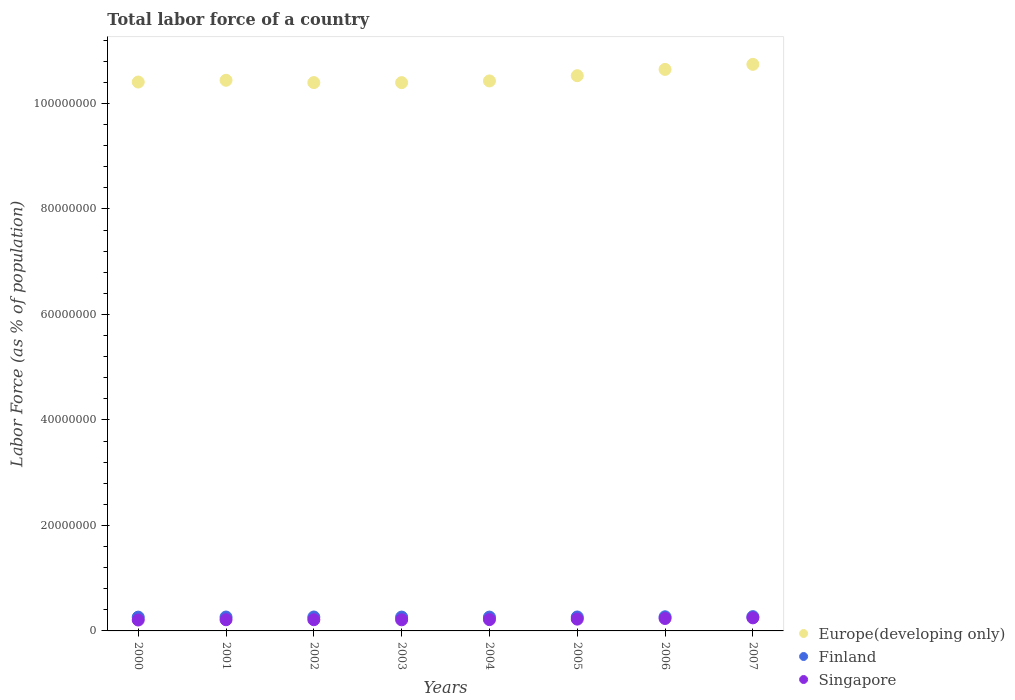How many different coloured dotlines are there?
Offer a terse response. 3. Is the number of dotlines equal to the number of legend labels?
Give a very brief answer. Yes. What is the percentage of labor force in Europe(developing only) in 2006?
Give a very brief answer. 1.06e+08. Across all years, what is the maximum percentage of labor force in Finland?
Give a very brief answer. 2.71e+06. Across all years, what is the minimum percentage of labor force in Singapore?
Your answer should be compact. 2.07e+06. In which year was the percentage of labor force in Europe(developing only) maximum?
Keep it short and to the point. 2007. In which year was the percentage of labor force in Finland minimum?
Keep it short and to the point. 2000. What is the total percentage of labor force in Finland in the graph?
Keep it short and to the point. 2.12e+07. What is the difference between the percentage of labor force in Finland in 2000 and that in 2003?
Your answer should be compact. -1.34e+04. What is the difference between the percentage of labor force in Finland in 2006 and the percentage of labor force in Europe(developing only) in 2002?
Offer a very short reply. -1.01e+08. What is the average percentage of labor force in Finland per year?
Provide a short and direct response. 2.65e+06. In the year 2002, what is the difference between the percentage of labor force in Finland and percentage of labor force in Singapore?
Your answer should be very brief. 5.14e+05. In how many years, is the percentage of labor force in Finland greater than 100000000 %?
Your answer should be compact. 0. What is the ratio of the percentage of labor force in Europe(developing only) in 2005 to that in 2007?
Make the answer very short. 0.98. Is the difference between the percentage of labor force in Finland in 2001 and 2006 greater than the difference between the percentage of labor force in Singapore in 2001 and 2006?
Provide a short and direct response. Yes. What is the difference between the highest and the second highest percentage of labor force in Singapore?
Your response must be concise. 1.21e+05. What is the difference between the highest and the lowest percentage of labor force in Finland?
Your answer should be very brief. 9.31e+04. Is the sum of the percentage of labor force in Finland in 2005 and 2007 greater than the maximum percentage of labor force in Singapore across all years?
Offer a very short reply. Yes. Does the percentage of labor force in Singapore monotonically increase over the years?
Ensure brevity in your answer.  No. How many dotlines are there?
Your answer should be compact. 3. What is the difference between two consecutive major ticks on the Y-axis?
Provide a short and direct response. 2.00e+07. Does the graph contain any zero values?
Make the answer very short. No. Where does the legend appear in the graph?
Make the answer very short. Bottom right. What is the title of the graph?
Your response must be concise. Total labor force of a country. Does "Central African Republic" appear as one of the legend labels in the graph?
Your answer should be very brief. No. What is the label or title of the Y-axis?
Provide a succinct answer. Labor Force (as % of population). What is the Labor Force (as % of population) in Europe(developing only) in 2000?
Offer a terse response. 1.04e+08. What is the Labor Force (as % of population) in Finland in 2000?
Ensure brevity in your answer.  2.61e+06. What is the Labor Force (as % of population) of Singapore in 2000?
Provide a succinct answer. 2.07e+06. What is the Labor Force (as % of population) in Europe(developing only) in 2001?
Provide a succinct answer. 1.04e+08. What is the Labor Force (as % of population) in Finland in 2001?
Ensure brevity in your answer.  2.63e+06. What is the Labor Force (as % of population) of Singapore in 2001?
Your answer should be very brief. 2.12e+06. What is the Labor Force (as % of population) of Europe(developing only) in 2002?
Keep it short and to the point. 1.04e+08. What is the Labor Force (as % of population) of Finland in 2002?
Offer a terse response. 2.64e+06. What is the Labor Force (as % of population) in Singapore in 2002?
Provide a short and direct response. 2.13e+06. What is the Labor Force (as % of population) of Europe(developing only) in 2003?
Keep it short and to the point. 1.04e+08. What is the Labor Force (as % of population) of Finland in 2003?
Offer a very short reply. 2.63e+06. What is the Labor Force (as % of population) in Singapore in 2003?
Offer a terse response. 2.11e+06. What is the Labor Force (as % of population) of Europe(developing only) in 2004?
Your response must be concise. 1.04e+08. What is the Labor Force (as % of population) in Finland in 2004?
Provide a succinct answer. 2.62e+06. What is the Labor Force (as % of population) of Singapore in 2004?
Provide a short and direct response. 2.14e+06. What is the Labor Force (as % of population) in Europe(developing only) in 2005?
Ensure brevity in your answer.  1.05e+08. What is the Labor Force (as % of population) in Finland in 2005?
Provide a short and direct response. 2.64e+06. What is the Labor Force (as % of population) in Singapore in 2005?
Offer a very short reply. 2.24e+06. What is the Labor Force (as % of population) of Europe(developing only) in 2006?
Provide a succinct answer. 1.06e+08. What is the Labor Force (as % of population) in Finland in 2006?
Your answer should be very brief. 2.68e+06. What is the Labor Force (as % of population) in Singapore in 2006?
Your response must be concise. 2.36e+06. What is the Labor Force (as % of population) of Europe(developing only) in 2007?
Offer a very short reply. 1.07e+08. What is the Labor Force (as % of population) of Finland in 2007?
Ensure brevity in your answer.  2.71e+06. What is the Labor Force (as % of population) in Singapore in 2007?
Provide a short and direct response. 2.48e+06. Across all years, what is the maximum Labor Force (as % of population) of Europe(developing only)?
Offer a terse response. 1.07e+08. Across all years, what is the maximum Labor Force (as % of population) in Finland?
Your answer should be compact. 2.71e+06. Across all years, what is the maximum Labor Force (as % of population) of Singapore?
Make the answer very short. 2.48e+06. Across all years, what is the minimum Labor Force (as % of population) of Europe(developing only)?
Provide a succinct answer. 1.04e+08. Across all years, what is the minimum Labor Force (as % of population) in Finland?
Ensure brevity in your answer.  2.61e+06. Across all years, what is the minimum Labor Force (as % of population) in Singapore?
Your answer should be compact. 2.07e+06. What is the total Labor Force (as % of population) in Europe(developing only) in the graph?
Provide a succinct answer. 8.40e+08. What is the total Labor Force (as % of population) of Finland in the graph?
Provide a short and direct response. 2.12e+07. What is the total Labor Force (as % of population) in Singapore in the graph?
Keep it short and to the point. 1.76e+07. What is the difference between the Labor Force (as % of population) in Europe(developing only) in 2000 and that in 2001?
Your answer should be compact. -3.35e+05. What is the difference between the Labor Force (as % of population) in Finland in 2000 and that in 2001?
Your answer should be very brief. -1.84e+04. What is the difference between the Labor Force (as % of population) of Singapore in 2000 and that in 2001?
Make the answer very short. -5.27e+04. What is the difference between the Labor Force (as % of population) of Europe(developing only) in 2000 and that in 2002?
Make the answer very short. 1.06e+05. What is the difference between the Labor Force (as % of population) in Finland in 2000 and that in 2002?
Make the answer very short. -2.54e+04. What is the difference between the Labor Force (as % of population) of Singapore in 2000 and that in 2002?
Give a very brief answer. -5.63e+04. What is the difference between the Labor Force (as % of population) of Europe(developing only) in 2000 and that in 2003?
Offer a terse response. 1.16e+05. What is the difference between the Labor Force (as % of population) in Finland in 2000 and that in 2003?
Provide a succinct answer. -1.34e+04. What is the difference between the Labor Force (as % of population) of Singapore in 2000 and that in 2003?
Keep it short and to the point. -3.64e+04. What is the difference between the Labor Force (as % of population) in Europe(developing only) in 2000 and that in 2004?
Your answer should be very brief. -2.07e+05. What is the difference between the Labor Force (as % of population) in Finland in 2000 and that in 2004?
Your response must be concise. -7622. What is the difference between the Labor Force (as % of population) of Singapore in 2000 and that in 2004?
Your answer should be very brief. -7.34e+04. What is the difference between the Labor Force (as % of population) in Europe(developing only) in 2000 and that in 2005?
Your response must be concise. -1.20e+06. What is the difference between the Labor Force (as % of population) of Finland in 2000 and that in 2005?
Ensure brevity in your answer.  -3.06e+04. What is the difference between the Labor Force (as % of population) of Singapore in 2000 and that in 2005?
Ensure brevity in your answer.  -1.69e+05. What is the difference between the Labor Force (as % of population) in Europe(developing only) in 2000 and that in 2006?
Your response must be concise. -2.40e+06. What is the difference between the Labor Force (as % of population) in Finland in 2000 and that in 2006?
Your answer should be compact. -6.70e+04. What is the difference between the Labor Force (as % of population) of Singapore in 2000 and that in 2006?
Give a very brief answer. -2.88e+05. What is the difference between the Labor Force (as % of population) of Europe(developing only) in 2000 and that in 2007?
Offer a very short reply. -3.35e+06. What is the difference between the Labor Force (as % of population) of Finland in 2000 and that in 2007?
Your response must be concise. -9.31e+04. What is the difference between the Labor Force (as % of population) in Singapore in 2000 and that in 2007?
Offer a terse response. -4.09e+05. What is the difference between the Labor Force (as % of population) in Europe(developing only) in 2001 and that in 2002?
Your response must be concise. 4.41e+05. What is the difference between the Labor Force (as % of population) of Finland in 2001 and that in 2002?
Provide a succinct answer. -7029. What is the difference between the Labor Force (as % of population) of Singapore in 2001 and that in 2002?
Your answer should be compact. -3507. What is the difference between the Labor Force (as % of population) in Europe(developing only) in 2001 and that in 2003?
Your answer should be compact. 4.51e+05. What is the difference between the Labor Force (as % of population) of Finland in 2001 and that in 2003?
Ensure brevity in your answer.  4950. What is the difference between the Labor Force (as % of population) of Singapore in 2001 and that in 2003?
Your response must be concise. 1.63e+04. What is the difference between the Labor Force (as % of population) of Europe(developing only) in 2001 and that in 2004?
Offer a terse response. 1.28e+05. What is the difference between the Labor Force (as % of population) of Finland in 2001 and that in 2004?
Your response must be concise. 1.08e+04. What is the difference between the Labor Force (as % of population) in Singapore in 2001 and that in 2004?
Offer a very short reply. -2.07e+04. What is the difference between the Labor Force (as % of population) in Europe(developing only) in 2001 and that in 2005?
Your answer should be compact. -8.66e+05. What is the difference between the Labor Force (as % of population) of Finland in 2001 and that in 2005?
Offer a very short reply. -1.22e+04. What is the difference between the Labor Force (as % of population) in Singapore in 2001 and that in 2005?
Offer a terse response. -1.17e+05. What is the difference between the Labor Force (as % of population) in Europe(developing only) in 2001 and that in 2006?
Provide a short and direct response. -2.06e+06. What is the difference between the Labor Force (as % of population) of Finland in 2001 and that in 2006?
Give a very brief answer. -4.86e+04. What is the difference between the Labor Force (as % of population) of Singapore in 2001 and that in 2006?
Ensure brevity in your answer.  -2.36e+05. What is the difference between the Labor Force (as % of population) of Europe(developing only) in 2001 and that in 2007?
Offer a very short reply. -3.02e+06. What is the difference between the Labor Force (as % of population) in Finland in 2001 and that in 2007?
Provide a short and direct response. -7.47e+04. What is the difference between the Labor Force (as % of population) in Singapore in 2001 and that in 2007?
Give a very brief answer. -3.56e+05. What is the difference between the Labor Force (as % of population) of Europe(developing only) in 2002 and that in 2003?
Provide a succinct answer. 1.04e+04. What is the difference between the Labor Force (as % of population) in Finland in 2002 and that in 2003?
Your response must be concise. 1.20e+04. What is the difference between the Labor Force (as % of population) of Singapore in 2002 and that in 2003?
Offer a very short reply. 1.98e+04. What is the difference between the Labor Force (as % of population) in Europe(developing only) in 2002 and that in 2004?
Your answer should be very brief. -3.12e+05. What is the difference between the Labor Force (as % of population) of Finland in 2002 and that in 2004?
Provide a succinct answer. 1.78e+04. What is the difference between the Labor Force (as % of population) in Singapore in 2002 and that in 2004?
Offer a terse response. -1.71e+04. What is the difference between the Labor Force (as % of population) in Europe(developing only) in 2002 and that in 2005?
Ensure brevity in your answer.  -1.31e+06. What is the difference between the Labor Force (as % of population) of Finland in 2002 and that in 2005?
Offer a very short reply. -5212. What is the difference between the Labor Force (as % of population) of Singapore in 2002 and that in 2005?
Provide a succinct answer. -1.13e+05. What is the difference between the Labor Force (as % of population) of Europe(developing only) in 2002 and that in 2006?
Offer a terse response. -2.50e+06. What is the difference between the Labor Force (as % of population) of Finland in 2002 and that in 2006?
Ensure brevity in your answer.  -4.16e+04. What is the difference between the Labor Force (as % of population) in Singapore in 2002 and that in 2006?
Your answer should be very brief. -2.32e+05. What is the difference between the Labor Force (as % of population) of Europe(developing only) in 2002 and that in 2007?
Your answer should be compact. -3.46e+06. What is the difference between the Labor Force (as % of population) in Finland in 2002 and that in 2007?
Your response must be concise. -6.77e+04. What is the difference between the Labor Force (as % of population) in Singapore in 2002 and that in 2007?
Your answer should be compact. -3.53e+05. What is the difference between the Labor Force (as % of population) in Europe(developing only) in 2003 and that in 2004?
Your answer should be very brief. -3.23e+05. What is the difference between the Labor Force (as % of population) in Finland in 2003 and that in 2004?
Offer a very short reply. 5801. What is the difference between the Labor Force (as % of population) of Singapore in 2003 and that in 2004?
Your response must be concise. -3.70e+04. What is the difference between the Labor Force (as % of population) in Europe(developing only) in 2003 and that in 2005?
Make the answer very short. -1.32e+06. What is the difference between the Labor Force (as % of population) of Finland in 2003 and that in 2005?
Ensure brevity in your answer.  -1.72e+04. What is the difference between the Labor Force (as % of population) of Singapore in 2003 and that in 2005?
Provide a succinct answer. -1.33e+05. What is the difference between the Labor Force (as % of population) in Europe(developing only) in 2003 and that in 2006?
Keep it short and to the point. -2.51e+06. What is the difference between the Labor Force (as % of population) in Finland in 2003 and that in 2006?
Offer a terse response. -5.36e+04. What is the difference between the Labor Force (as % of population) in Singapore in 2003 and that in 2006?
Make the answer very short. -2.52e+05. What is the difference between the Labor Force (as % of population) in Europe(developing only) in 2003 and that in 2007?
Keep it short and to the point. -3.47e+06. What is the difference between the Labor Force (as % of population) of Finland in 2003 and that in 2007?
Provide a short and direct response. -7.96e+04. What is the difference between the Labor Force (as % of population) in Singapore in 2003 and that in 2007?
Provide a succinct answer. -3.73e+05. What is the difference between the Labor Force (as % of population) of Europe(developing only) in 2004 and that in 2005?
Your answer should be very brief. -9.95e+05. What is the difference between the Labor Force (as % of population) in Finland in 2004 and that in 2005?
Your answer should be compact. -2.30e+04. What is the difference between the Labor Force (as % of population) of Singapore in 2004 and that in 2005?
Provide a short and direct response. -9.61e+04. What is the difference between the Labor Force (as % of population) in Europe(developing only) in 2004 and that in 2006?
Ensure brevity in your answer.  -2.19e+06. What is the difference between the Labor Force (as % of population) in Finland in 2004 and that in 2006?
Provide a short and direct response. -5.94e+04. What is the difference between the Labor Force (as % of population) in Singapore in 2004 and that in 2006?
Offer a very short reply. -2.15e+05. What is the difference between the Labor Force (as % of population) of Europe(developing only) in 2004 and that in 2007?
Keep it short and to the point. -3.14e+06. What is the difference between the Labor Force (as % of population) of Finland in 2004 and that in 2007?
Give a very brief answer. -8.54e+04. What is the difference between the Labor Force (as % of population) in Singapore in 2004 and that in 2007?
Keep it short and to the point. -3.36e+05. What is the difference between the Labor Force (as % of population) in Europe(developing only) in 2005 and that in 2006?
Provide a succinct answer. -1.19e+06. What is the difference between the Labor Force (as % of population) of Finland in 2005 and that in 2006?
Your answer should be compact. -3.64e+04. What is the difference between the Labor Force (as % of population) of Singapore in 2005 and that in 2006?
Provide a short and direct response. -1.19e+05. What is the difference between the Labor Force (as % of population) of Europe(developing only) in 2005 and that in 2007?
Provide a short and direct response. -2.15e+06. What is the difference between the Labor Force (as % of population) of Finland in 2005 and that in 2007?
Your answer should be compact. -6.25e+04. What is the difference between the Labor Force (as % of population) in Singapore in 2005 and that in 2007?
Give a very brief answer. -2.40e+05. What is the difference between the Labor Force (as % of population) of Europe(developing only) in 2006 and that in 2007?
Offer a very short reply. -9.56e+05. What is the difference between the Labor Force (as % of population) of Finland in 2006 and that in 2007?
Provide a succinct answer. -2.61e+04. What is the difference between the Labor Force (as % of population) in Singapore in 2006 and that in 2007?
Offer a terse response. -1.21e+05. What is the difference between the Labor Force (as % of population) in Europe(developing only) in 2000 and the Labor Force (as % of population) in Finland in 2001?
Make the answer very short. 1.01e+08. What is the difference between the Labor Force (as % of population) in Europe(developing only) in 2000 and the Labor Force (as % of population) in Singapore in 2001?
Provide a short and direct response. 1.02e+08. What is the difference between the Labor Force (as % of population) of Finland in 2000 and the Labor Force (as % of population) of Singapore in 2001?
Provide a short and direct response. 4.92e+05. What is the difference between the Labor Force (as % of population) in Europe(developing only) in 2000 and the Labor Force (as % of population) in Finland in 2002?
Make the answer very short. 1.01e+08. What is the difference between the Labor Force (as % of population) in Europe(developing only) in 2000 and the Labor Force (as % of population) in Singapore in 2002?
Your answer should be very brief. 1.02e+08. What is the difference between the Labor Force (as % of population) in Finland in 2000 and the Labor Force (as % of population) in Singapore in 2002?
Give a very brief answer. 4.89e+05. What is the difference between the Labor Force (as % of population) of Europe(developing only) in 2000 and the Labor Force (as % of population) of Finland in 2003?
Provide a succinct answer. 1.01e+08. What is the difference between the Labor Force (as % of population) in Europe(developing only) in 2000 and the Labor Force (as % of population) in Singapore in 2003?
Make the answer very short. 1.02e+08. What is the difference between the Labor Force (as % of population) in Finland in 2000 and the Labor Force (as % of population) in Singapore in 2003?
Offer a very short reply. 5.09e+05. What is the difference between the Labor Force (as % of population) of Europe(developing only) in 2000 and the Labor Force (as % of population) of Finland in 2004?
Make the answer very short. 1.01e+08. What is the difference between the Labor Force (as % of population) of Europe(developing only) in 2000 and the Labor Force (as % of population) of Singapore in 2004?
Your answer should be compact. 1.02e+08. What is the difference between the Labor Force (as % of population) in Finland in 2000 and the Labor Force (as % of population) in Singapore in 2004?
Offer a very short reply. 4.72e+05. What is the difference between the Labor Force (as % of population) in Europe(developing only) in 2000 and the Labor Force (as % of population) in Finland in 2005?
Make the answer very short. 1.01e+08. What is the difference between the Labor Force (as % of population) in Europe(developing only) in 2000 and the Labor Force (as % of population) in Singapore in 2005?
Provide a succinct answer. 1.02e+08. What is the difference between the Labor Force (as % of population) in Finland in 2000 and the Labor Force (as % of population) in Singapore in 2005?
Ensure brevity in your answer.  3.76e+05. What is the difference between the Labor Force (as % of population) of Europe(developing only) in 2000 and the Labor Force (as % of population) of Finland in 2006?
Give a very brief answer. 1.01e+08. What is the difference between the Labor Force (as % of population) in Europe(developing only) in 2000 and the Labor Force (as % of population) in Singapore in 2006?
Ensure brevity in your answer.  1.02e+08. What is the difference between the Labor Force (as % of population) of Finland in 2000 and the Labor Force (as % of population) of Singapore in 2006?
Provide a succinct answer. 2.57e+05. What is the difference between the Labor Force (as % of population) in Europe(developing only) in 2000 and the Labor Force (as % of population) in Finland in 2007?
Your answer should be compact. 1.01e+08. What is the difference between the Labor Force (as % of population) in Europe(developing only) in 2000 and the Labor Force (as % of population) in Singapore in 2007?
Your response must be concise. 1.02e+08. What is the difference between the Labor Force (as % of population) in Finland in 2000 and the Labor Force (as % of population) in Singapore in 2007?
Give a very brief answer. 1.36e+05. What is the difference between the Labor Force (as % of population) of Europe(developing only) in 2001 and the Labor Force (as % of population) of Finland in 2002?
Offer a terse response. 1.02e+08. What is the difference between the Labor Force (as % of population) in Europe(developing only) in 2001 and the Labor Force (as % of population) in Singapore in 2002?
Ensure brevity in your answer.  1.02e+08. What is the difference between the Labor Force (as % of population) in Finland in 2001 and the Labor Force (as % of population) in Singapore in 2002?
Give a very brief answer. 5.07e+05. What is the difference between the Labor Force (as % of population) in Europe(developing only) in 2001 and the Labor Force (as % of population) in Finland in 2003?
Your answer should be compact. 1.02e+08. What is the difference between the Labor Force (as % of population) of Europe(developing only) in 2001 and the Labor Force (as % of population) of Singapore in 2003?
Your response must be concise. 1.02e+08. What is the difference between the Labor Force (as % of population) in Finland in 2001 and the Labor Force (as % of population) in Singapore in 2003?
Keep it short and to the point. 5.27e+05. What is the difference between the Labor Force (as % of population) of Europe(developing only) in 2001 and the Labor Force (as % of population) of Finland in 2004?
Your answer should be compact. 1.02e+08. What is the difference between the Labor Force (as % of population) in Europe(developing only) in 2001 and the Labor Force (as % of population) in Singapore in 2004?
Your answer should be compact. 1.02e+08. What is the difference between the Labor Force (as % of population) in Finland in 2001 and the Labor Force (as % of population) in Singapore in 2004?
Provide a short and direct response. 4.90e+05. What is the difference between the Labor Force (as % of population) in Europe(developing only) in 2001 and the Labor Force (as % of population) in Finland in 2005?
Give a very brief answer. 1.02e+08. What is the difference between the Labor Force (as % of population) in Europe(developing only) in 2001 and the Labor Force (as % of population) in Singapore in 2005?
Provide a succinct answer. 1.02e+08. What is the difference between the Labor Force (as % of population) of Finland in 2001 and the Labor Force (as % of population) of Singapore in 2005?
Keep it short and to the point. 3.94e+05. What is the difference between the Labor Force (as % of population) of Europe(developing only) in 2001 and the Labor Force (as % of population) of Finland in 2006?
Keep it short and to the point. 1.02e+08. What is the difference between the Labor Force (as % of population) in Europe(developing only) in 2001 and the Labor Force (as % of population) in Singapore in 2006?
Keep it short and to the point. 1.02e+08. What is the difference between the Labor Force (as % of population) of Finland in 2001 and the Labor Force (as % of population) of Singapore in 2006?
Your answer should be very brief. 2.75e+05. What is the difference between the Labor Force (as % of population) in Europe(developing only) in 2001 and the Labor Force (as % of population) in Finland in 2007?
Your answer should be very brief. 1.02e+08. What is the difference between the Labor Force (as % of population) of Europe(developing only) in 2001 and the Labor Force (as % of population) of Singapore in 2007?
Ensure brevity in your answer.  1.02e+08. What is the difference between the Labor Force (as % of population) of Finland in 2001 and the Labor Force (as % of population) of Singapore in 2007?
Your answer should be compact. 1.54e+05. What is the difference between the Labor Force (as % of population) of Europe(developing only) in 2002 and the Labor Force (as % of population) of Finland in 2003?
Your answer should be very brief. 1.01e+08. What is the difference between the Labor Force (as % of population) of Europe(developing only) in 2002 and the Labor Force (as % of population) of Singapore in 2003?
Ensure brevity in your answer.  1.02e+08. What is the difference between the Labor Force (as % of population) of Finland in 2002 and the Labor Force (as % of population) of Singapore in 2003?
Keep it short and to the point. 5.34e+05. What is the difference between the Labor Force (as % of population) of Europe(developing only) in 2002 and the Labor Force (as % of population) of Finland in 2004?
Your answer should be very brief. 1.01e+08. What is the difference between the Labor Force (as % of population) in Europe(developing only) in 2002 and the Labor Force (as % of population) in Singapore in 2004?
Make the answer very short. 1.02e+08. What is the difference between the Labor Force (as % of population) of Finland in 2002 and the Labor Force (as % of population) of Singapore in 2004?
Ensure brevity in your answer.  4.97e+05. What is the difference between the Labor Force (as % of population) of Europe(developing only) in 2002 and the Labor Force (as % of population) of Finland in 2005?
Offer a terse response. 1.01e+08. What is the difference between the Labor Force (as % of population) of Europe(developing only) in 2002 and the Labor Force (as % of population) of Singapore in 2005?
Your answer should be compact. 1.02e+08. What is the difference between the Labor Force (as % of population) in Finland in 2002 and the Labor Force (as % of population) in Singapore in 2005?
Offer a very short reply. 4.01e+05. What is the difference between the Labor Force (as % of population) of Europe(developing only) in 2002 and the Labor Force (as % of population) of Finland in 2006?
Provide a succinct answer. 1.01e+08. What is the difference between the Labor Force (as % of population) in Europe(developing only) in 2002 and the Labor Force (as % of population) in Singapore in 2006?
Provide a succinct answer. 1.02e+08. What is the difference between the Labor Force (as % of population) of Finland in 2002 and the Labor Force (as % of population) of Singapore in 2006?
Provide a short and direct response. 2.82e+05. What is the difference between the Labor Force (as % of population) in Europe(developing only) in 2002 and the Labor Force (as % of population) in Finland in 2007?
Offer a very short reply. 1.01e+08. What is the difference between the Labor Force (as % of population) in Europe(developing only) in 2002 and the Labor Force (as % of population) in Singapore in 2007?
Your answer should be compact. 1.01e+08. What is the difference between the Labor Force (as % of population) of Finland in 2002 and the Labor Force (as % of population) of Singapore in 2007?
Offer a very short reply. 1.61e+05. What is the difference between the Labor Force (as % of population) in Europe(developing only) in 2003 and the Labor Force (as % of population) in Finland in 2004?
Your response must be concise. 1.01e+08. What is the difference between the Labor Force (as % of population) in Europe(developing only) in 2003 and the Labor Force (as % of population) in Singapore in 2004?
Your response must be concise. 1.02e+08. What is the difference between the Labor Force (as % of population) in Finland in 2003 and the Labor Force (as % of population) in Singapore in 2004?
Give a very brief answer. 4.85e+05. What is the difference between the Labor Force (as % of population) in Europe(developing only) in 2003 and the Labor Force (as % of population) in Finland in 2005?
Offer a very short reply. 1.01e+08. What is the difference between the Labor Force (as % of population) in Europe(developing only) in 2003 and the Labor Force (as % of population) in Singapore in 2005?
Offer a terse response. 1.02e+08. What is the difference between the Labor Force (as % of population) in Finland in 2003 and the Labor Force (as % of population) in Singapore in 2005?
Offer a terse response. 3.89e+05. What is the difference between the Labor Force (as % of population) of Europe(developing only) in 2003 and the Labor Force (as % of population) of Finland in 2006?
Provide a succinct answer. 1.01e+08. What is the difference between the Labor Force (as % of population) of Europe(developing only) in 2003 and the Labor Force (as % of population) of Singapore in 2006?
Keep it short and to the point. 1.02e+08. What is the difference between the Labor Force (as % of population) of Finland in 2003 and the Labor Force (as % of population) of Singapore in 2006?
Your answer should be compact. 2.70e+05. What is the difference between the Labor Force (as % of population) of Europe(developing only) in 2003 and the Labor Force (as % of population) of Finland in 2007?
Provide a short and direct response. 1.01e+08. What is the difference between the Labor Force (as % of population) of Europe(developing only) in 2003 and the Labor Force (as % of population) of Singapore in 2007?
Offer a very short reply. 1.01e+08. What is the difference between the Labor Force (as % of population) in Finland in 2003 and the Labor Force (as % of population) in Singapore in 2007?
Make the answer very short. 1.49e+05. What is the difference between the Labor Force (as % of population) of Europe(developing only) in 2004 and the Labor Force (as % of population) of Finland in 2005?
Offer a terse response. 1.02e+08. What is the difference between the Labor Force (as % of population) of Europe(developing only) in 2004 and the Labor Force (as % of population) of Singapore in 2005?
Offer a terse response. 1.02e+08. What is the difference between the Labor Force (as % of population) in Finland in 2004 and the Labor Force (as % of population) in Singapore in 2005?
Your answer should be compact. 3.83e+05. What is the difference between the Labor Force (as % of population) of Europe(developing only) in 2004 and the Labor Force (as % of population) of Finland in 2006?
Ensure brevity in your answer.  1.02e+08. What is the difference between the Labor Force (as % of population) of Europe(developing only) in 2004 and the Labor Force (as % of population) of Singapore in 2006?
Your answer should be compact. 1.02e+08. What is the difference between the Labor Force (as % of population) of Finland in 2004 and the Labor Force (as % of population) of Singapore in 2006?
Offer a terse response. 2.64e+05. What is the difference between the Labor Force (as % of population) of Europe(developing only) in 2004 and the Labor Force (as % of population) of Finland in 2007?
Your answer should be compact. 1.02e+08. What is the difference between the Labor Force (as % of population) of Europe(developing only) in 2004 and the Labor Force (as % of population) of Singapore in 2007?
Make the answer very short. 1.02e+08. What is the difference between the Labor Force (as % of population) of Finland in 2004 and the Labor Force (as % of population) of Singapore in 2007?
Provide a succinct answer. 1.44e+05. What is the difference between the Labor Force (as % of population) in Europe(developing only) in 2005 and the Labor Force (as % of population) in Finland in 2006?
Your response must be concise. 1.03e+08. What is the difference between the Labor Force (as % of population) in Europe(developing only) in 2005 and the Labor Force (as % of population) in Singapore in 2006?
Your response must be concise. 1.03e+08. What is the difference between the Labor Force (as % of population) in Finland in 2005 and the Labor Force (as % of population) in Singapore in 2006?
Provide a short and direct response. 2.87e+05. What is the difference between the Labor Force (as % of population) in Europe(developing only) in 2005 and the Labor Force (as % of population) in Finland in 2007?
Offer a very short reply. 1.03e+08. What is the difference between the Labor Force (as % of population) of Europe(developing only) in 2005 and the Labor Force (as % of population) of Singapore in 2007?
Offer a terse response. 1.03e+08. What is the difference between the Labor Force (as % of population) of Finland in 2005 and the Labor Force (as % of population) of Singapore in 2007?
Your response must be concise. 1.67e+05. What is the difference between the Labor Force (as % of population) of Europe(developing only) in 2006 and the Labor Force (as % of population) of Finland in 2007?
Make the answer very short. 1.04e+08. What is the difference between the Labor Force (as % of population) in Europe(developing only) in 2006 and the Labor Force (as % of population) in Singapore in 2007?
Your answer should be compact. 1.04e+08. What is the difference between the Labor Force (as % of population) in Finland in 2006 and the Labor Force (as % of population) in Singapore in 2007?
Give a very brief answer. 2.03e+05. What is the average Labor Force (as % of population) of Europe(developing only) per year?
Your response must be concise. 1.05e+08. What is the average Labor Force (as % of population) of Finland per year?
Ensure brevity in your answer.  2.65e+06. What is the average Labor Force (as % of population) of Singapore per year?
Ensure brevity in your answer.  2.20e+06. In the year 2000, what is the difference between the Labor Force (as % of population) of Europe(developing only) and Labor Force (as % of population) of Finland?
Give a very brief answer. 1.01e+08. In the year 2000, what is the difference between the Labor Force (as % of population) in Europe(developing only) and Labor Force (as % of population) in Singapore?
Your answer should be compact. 1.02e+08. In the year 2000, what is the difference between the Labor Force (as % of population) of Finland and Labor Force (as % of population) of Singapore?
Provide a short and direct response. 5.45e+05. In the year 2001, what is the difference between the Labor Force (as % of population) of Europe(developing only) and Labor Force (as % of population) of Finland?
Keep it short and to the point. 1.02e+08. In the year 2001, what is the difference between the Labor Force (as % of population) of Europe(developing only) and Labor Force (as % of population) of Singapore?
Give a very brief answer. 1.02e+08. In the year 2001, what is the difference between the Labor Force (as % of population) in Finland and Labor Force (as % of population) in Singapore?
Make the answer very short. 5.11e+05. In the year 2002, what is the difference between the Labor Force (as % of population) in Europe(developing only) and Labor Force (as % of population) in Finland?
Provide a short and direct response. 1.01e+08. In the year 2002, what is the difference between the Labor Force (as % of population) of Europe(developing only) and Labor Force (as % of population) of Singapore?
Ensure brevity in your answer.  1.02e+08. In the year 2002, what is the difference between the Labor Force (as % of population) of Finland and Labor Force (as % of population) of Singapore?
Keep it short and to the point. 5.14e+05. In the year 2003, what is the difference between the Labor Force (as % of population) in Europe(developing only) and Labor Force (as % of population) in Finland?
Provide a short and direct response. 1.01e+08. In the year 2003, what is the difference between the Labor Force (as % of population) in Europe(developing only) and Labor Force (as % of population) in Singapore?
Offer a very short reply. 1.02e+08. In the year 2003, what is the difference between the Labor Force (as % of population) of Finland and Labor Force (as % of population) of Singapore?
Provide a short and direct response. 5.22e+05. In the year 2004, what is the difference between the Labor Force (as % of population) in Europe(developing only) and Labor Force (as % of population) in Finland?
Your response must be concise. 1.02e+08. In the year 2004, what is the difference between the Labor Force (as % of population) of Europe(developing only) and Labor Force (as % of population) of Singapore?
Your answer should be compact. 1.02e+08. In the year 2004, what is the difference between the Labor Force (as % of population) of Finland and Labor Force (as % of population) of Singapore?
Your answer should be very brief. 4.79e+05. In the year 2005, what is the difference between the Labor Force (as % of population) of Europe(developing only) and Labor Force (as % of population) of Finland?
Your answer should be compact. 1.03e+08. In the year 2005, what is the difference between the Labor Force (as % of population) of Europe(developing only) and Labor Force (as % of population) of Singapore?
Keep it short and to the point. 1.03e+08. In the year 2005, what is the difference between the Labor Force (as % of population) of Finland and Labor Force (as % of population) of Singapore?
Your answer should be compact. 4.06e+05. In the year 2006, what is the difference between the Labor Force (as % of population) in Europe(developing only) and Labor Force (as % of population) in Finland?
Offer a very short reply. 1.04e+08. In the year 2006, what is the difference between the Labor Force (as % of population) of Europe(developing only) and Labor Force (as % of population) of Singapore?
Your answer should be very brief. 1.04e+08. In the year 2006, what is the difference between the Labor Force (as % of population) in Finland and Labor Force (as % of population) in Singapore?
Give a very brief answer. 3.24e+05. In the year 2007, what is the difference between the Labor Force (as % of population) of Europe(developing only) and Labor Force (as % of population) of Finland?
Give a very brief answer. 1.05e+08. In the year 2007, what is the difference between the Labor Force (as % of population) of Europe(developing only) and Labor Force (as % of population) of Singapore?
Keep it short and to the point. 1.05e+08. In the year 2007, what is the difference between the Labor Force (as % of population) in Finland and Labor Force (as % of population) in Singapore?
Offer a very short reply. 2.29e+05. What is the ratio of the Labor Force (as % of population) of Finland in 2000 to that in 2001?
Your answer should be compact. 0.99. What is the ratio of the Labor Force (as % of population) of Singapore in 2000 to that in 2001?
Your response must be concise. 0.98. What is the ratio of the Labor Force (as % of population) in Europe(developing only) in 2000 to that in 2002?
Make the answer very short. 1. What is the ratio of the Labor Force (as % of population) of Singapore in 2000 to that in 2002?
Ensure brevity in your answer.  0.97. What is the ratio of the Labor Force (as % of population) in Europe(developing only) in 2000 to that in 2003?
Provide a succinct answer. 1. What is the ratio of the Labor Force (as % of population) of Singapore in 2000 to that in 2003?
Give a very brief answer. 0.98. What is the ratio of the Labor Force (as % of population) of Singapore in 2000 to that in 2004?
Give a very brief answer. 0.97. What is the ratio of the Labor Force (as % of population) of Europe(developing only) in 2000 to that in 2005?
Offer a very short reply. 0.99. What is the ratio of the Labor Force (as % of population) in Finland in 2000 to that in 2005?
Keep it short and to the point. 0.99. What is the ratio of the Labor Force (as % of population) of Singapore in 2000 to that in 2005?
Your answer should be compact. 0.92. What is the ratio of the Labor Force (as % of population) of Europe(developing only) in 2000 to that in 2006?
Your answer should be very brief. 0.98. What is the ratio of the Labor Force (as % of population) of Finland in 2000 to that in 2006?
Offer a very short reply. 0.97. What is the ratio of the Labor Force (as % of population) in Singapore in 2000 to that in 2006?
Your response must be concise. 0.88. What is the ratio of the Labor Force (as % of population) of Europe(developing only) in 2000 to that in 2007?
Ensure brevity in your answer.  0.97. What is the ratio of the Labor Force (as % of population) in Finland in 2000 to that in 2007?
Your response must be concise. 0.97. What is the ratio of the Labor Force (as % of population) in Singapore in 2000 to that in 2007?
Offer a very short reply. 0.83. What is the ratio of the Labor Force (as % of population) in Singapore in 2001 to that in 2002?
Your answer should be very brief. 1. What is the ratio of the Labor Force (as % of population) of Finland in 2001 to that in 2003?
Make the answer very short. 1. What is the ratio of the Labor Force (as % of population) of Singapore in 2001 to that in 2003?
Provide a short and direct response. 1.01. What is the ratio of the Labor Force (as % of population) of Europe(developing only) in 2001 to that in 2004?
Offer a very short reply. 1. What is the ratio of the Labor Force (as % of population) of Singapore in 2001 to that in 2004?
Your response must be concise. 0.99. What is the ratio of the Labor Force (as % of population) in Europe(developing only) in 2001 to that in 2005?
Keep it short and to the point. 0.99. What is the ratio of the Labor Force (as % of population) of Finland in 2001 to that in 2005?
Ensure brevity in your answer.  1. What is the ratio of the Labor Force (as % of population) in Singapore in 2001 to that in 2005?
Your answer should be very brief. 0.95. What is the ratio of the Labor Force (as % of population) of Europe(developing only) in 2001 to that in 2006?
Keep it short and to the point. 0.98. What is the ratio of the Labor Force (as % of population) of Finland in 2001 to that in 2006?
Offer a very short reply. 0.98. What is the ratio of the Labor Force (as % of population) in Europe(developing only) in 2001 to that in 2007?
Offer a very short reply. 0.97. What is the ratio of the Labor Force (as % of population) of Finland in 2001 to that in 2007?
Provide a succinct answer. 0.97. What is the ratio of the Labor Force (as % of population) in Singapore in 2001 to that in 2007?
Your response must be concise. 0.86. What is the ratio of the Labor Force (as % of population) of Europe(developing only) in 2002 to that in 2003?
Your response must be concise. 1. What is the ratio of the Labor Force (as % of population) in Singapore in 2002 to that in 2003?
Provide a succinct answer. 1.01. What is the ratio of the Labor Force (as % of population) in Europe(developing only) in 2002 to that in 2004?
Keep it short and to the point. 1. What is the ratio of the Labor Force (as % of population) of Finland in 2002 to that in 2004?
Provide a short and direct response. 1.01. What is the ratio of the Labor Force (as % of population) in Singapore in 2002 to that in 2004?
Your answer should be very brief. 0.99. What is the ratio of the Labor Force (as % of population) in Europe(developing only) in 2002 to that in 2005?
Provide a succinct answer. 0.99. What is the ratio of the Labor Force (as % of population) in Singapore in 2002 to that in 2005?
Your response must be concise. 0.95. What is the ratio of the Labor Force (as % of population) in Europe(developing only) in 2002 to that in 2006?
Ensure brevity in your answer.  0.98. What is the ratio of the Labor Force (as % of population) of Finland in 2002 to that in 2006?
Offer a terse response. 0.98. What is the ratio of the Labor Force (as % of population) of Singapore in 2002 to that in 2006?
Ensure brevity in your answer.  0.9. What is the ratio of the Labor Force (as % of population) of Europe(developing only) in 2002 to that in 2007?
Provide a short and direct response. 0.97. What is the ratio of the Labor Force (as % of population) of Singapore in 2002 to that in 2007?
Your answer should be compact. 0.86. What is the ratio of the Labor Force (as % of population) in Singapore in 2003 to that in 2004?
Make the answer very short. 0.98. What is the ratio of the Labor Force (as % of population) of Europe(developing only) in 2003 to that in 2005?
Keep it short and to the point. 0.99. What is the ratio of the Labor Force (as % of population) in Finland in 2003 to that in 2005?
Offer a terse response. 0.99. What is the ratio of the Labor Force (as % of population) of Singapore in 2003 to that in 2005?
Offer a very short reply. 0.94. What is the ratio of the Labor Force (as % of population) of Europe(developing only) in 2003 to that in 2006?
Your answer should be very brief. 0.98. What is the ratio of the Labor Force (as % of population) in Finland in 2003 to that in 2006?
Offer a very short reply. 0.98. What is the ratio of the Labor Force (as % of population) in Singapore in 2003 to that in 2006?
Give a very brief answer. 0.89. What is the ratio of the Labor Force (as % of population) of Europe(developing only) in 2003 to that in 2007?
Provide a short and direct response. 0.97. What is the ratio of the Labor Force (as % of population) in Finland in 2003 to that in 2007?
Offer a very short reply. 0.97. What is the ratio of the Labor Force (as % of population) of Singapore in 2003 to that in 2007?
Offer a terse response. 0.85. What is the ratio of the Labor Force (as % of population) in Europe(developing only) in 2004 to that in 2005?
Provide a succinct answer. 0.99. What is the ratio of the Labor Force (as % of population) of Finland in 2004 to that in 2005?
Your answer should be compact. 0.99. What is the ratio of the Labor Force (as % of population) in Singapore in 2004 to that in 2005?
Give a very brief answer. 0.96. What is the ratio of the Labor Force (as % of population) in Europe(developing only) in 2004 to that in 2006?
Provide a short and direct response. 0.98. What is the ratio of the Labor Force (as % of population) of Finland in 2004 to that in 2006?
Provide a succinct answer. 0.98. What is the ratio of the Labor Force (as % of population) of Singapore in 2004 to that in 2006?
Keep it short and to the point. 0.91. What is the ratio of the Labor Force (as % of population) in Europe(developing only) in 2004 to that in 2007?
Your answer should be compact. 0.97. What is the ratio of the Labor Force (as % of population) of Finland in 2004 to that in 2007?
Make the answer very short. 0.97. What is the ratio of the Labor Force (as % of population) of Singapore in 2004 to that in 2007?
Keep it short and to the point. 0.86. What is the ratio of the Labor Force (as % of population) of Finland in 2005 to that in 2006?
Provide a short and direct response. 0.99. What is the ratio of the Labor Force (as % of population) in Singapore in 2005 to that in 2006?
Give a very brief answer. 0.95. What is the ratio of the Labor Force (as % of population) of Finland in 2005 to that in 2007?
Give a very brief answer. 0.98. What is the ratio of the Labor Force (as % of population) in Singapore in 2005 to that in 2007?
Provide a succinct answer. 0.9. What is the ratio of the Labor Force (as % of population) of Singapore in 2006 to that in 2007?
Your response must be concise. 0.95. What is the difference between the highest and the second highest Labor Force (as % of population) of Europe(developing only)?
Your answer should be very brief. 9.56e+05. What is the difference between the highest and the second highest Labor Force (as % of population) of Finland?
Provide a short and direct response. 2.61e+04. What is the difference between the highest and the second highest Labor Force (as % of population) of Singapore?
Your response must be concise. 1.21e+05. What is the difference between the highest and the lowest Labor Force (as % of population) in Europe(developing only)?
Offer a very short reply. 3.47e+06. What is the difference between the highest and the lowest Labor Force (as % of population) of Finland?
Offer a very short reply. 9.31e+04. What is the difference between the highest and the lowest Labor Force (as % of population) in Singapore?
Make the answer very short. 4.09e+05. 